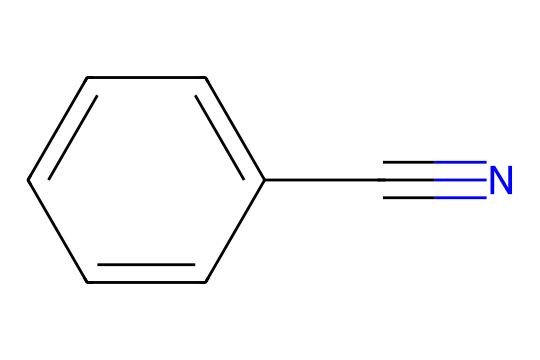What is the name of this chemical? The SMILES notation provided corresponds to a compound with a phenyl ring (c1ccccc1) attached to a nitrile group (C#N). This structural characteristic identifies it as benzonitrile.
Answer: benzonitrile How many carbon atoms are in benzonitrile? The chemical structure represented by the SMILES shows a six-membered aromatic ring (phenyl) which contains six carbon atoms, plus one additional carbon from the nitrile group (C#N), totaling seven carbon atoms.
Answer: 7 What functional group is present in benzonitrile? The compound includes a nitrile functional group, which is characterized by the presence of the carbon triple-bonded to nitrogen (C#N). This distinguishes it as a nitrile.
Answer: nitrile What is the total number of hydrogen atoms in benzonitrile? The phenyl part of the structure contributes five hydrogen atoms (on the six-membered ring, with one hydrogen replaced by the nitrile group). Therefore, the total number of hydrogen atoms is five.
Answer: 5 Does benzonitrile exhibit polarity? Considering the structure, the polar nitrile group (C#N) can induce a dipole moment, suggesting that the overall molecule has some degree of polarity despite the non-polar character of the phenyl ring, leading to a conclusion of moderate polarity.
Answer: moderate What types of chemical reactions can benzonitrile undergo? Benzonitrile can participate in nucleophilic reactions, especially involving the nitrile group, allowing it to form amines or carboxylic acids through hydrolysis or other related transformations. This behavior is typical for nitriles.
Answer: nucleophilic reactions Is benzonitrile soluble in water? The nitrile group confers some degree of solubility in water; however, the aromatic structure limits it, resulting in limited water solubility. Many nitriles have low to moderate solubility in aqueous solutions.
Answer: limited 